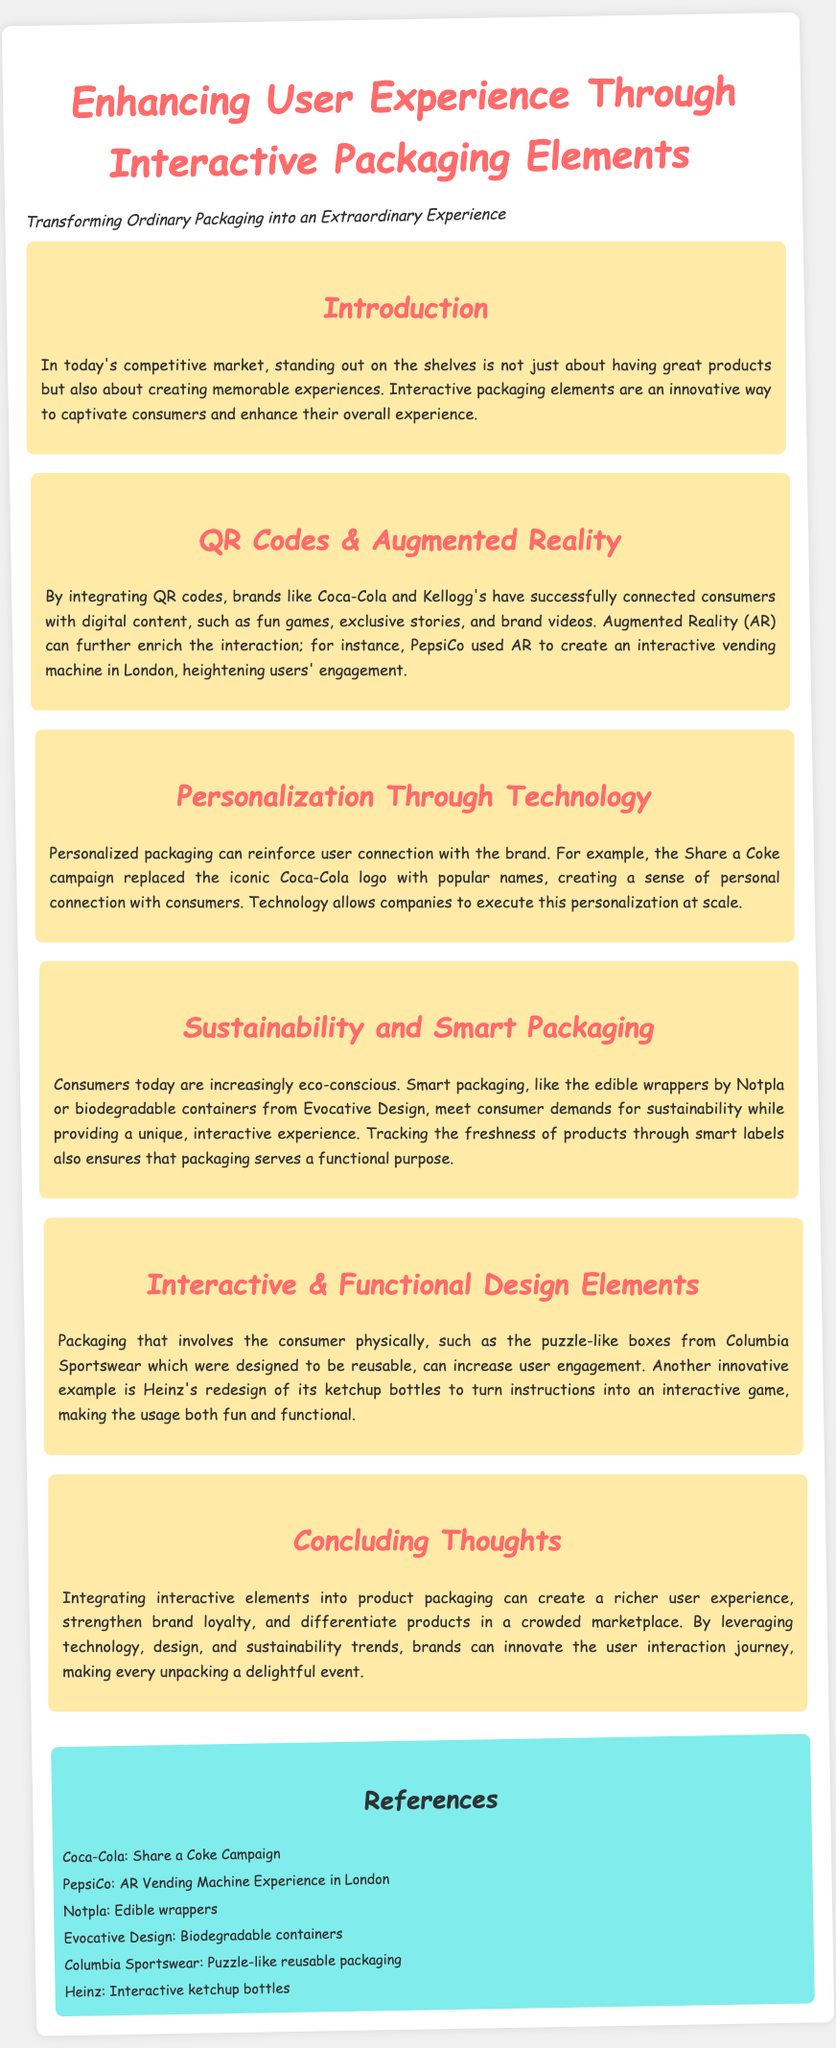what is the title of the document? The title of the document is stated at the top as "Enhancing User Experience Through Interactive Packaging Elements."
Answer: Enhancing User Experience Through Interactive Packaging Elements who implemented the Share a Coke campaign? The document mentions Coca-Cola in relation to the Share a Coke campaign, which involved personalized packaging.
Answer: Coca-Cola what interactive element does PepsiCo use in London? The document states that PepsiCo used Augmented Reality to create an interactive vending machine in London.
Answer: Augmented Reality what is the main purpose of smart packaging according to the document? Smart packaging is highlighted in the document as meeting consumer demands for sustainability while providing a unique interactive experience.
Answer: Sustainability what type of design did Columbia Sportswear utilize in their packaging? The document describes the puzzle-like boxes from Columbia Sportswear, which were designed to be reusable.
Answer: Puzzle-like boxes how can integrating interactive elements into packaging benefit brands? The document concludes that integrating interactive elements can create a richer user experience and strengthen brand loyalty.
Answer: Richer user experience and brand loyalty what does Notpla create for packaging? The document mentions Notpla's edible wrappers as an innovative packaging solution.
Answer: Edible wrappers what was a design change made by Heinz for their ketchup bottles? The document explains that Heinz redesigned its ketchup bottles to turn instructions into an interactive game.
Answer: Interactive game 